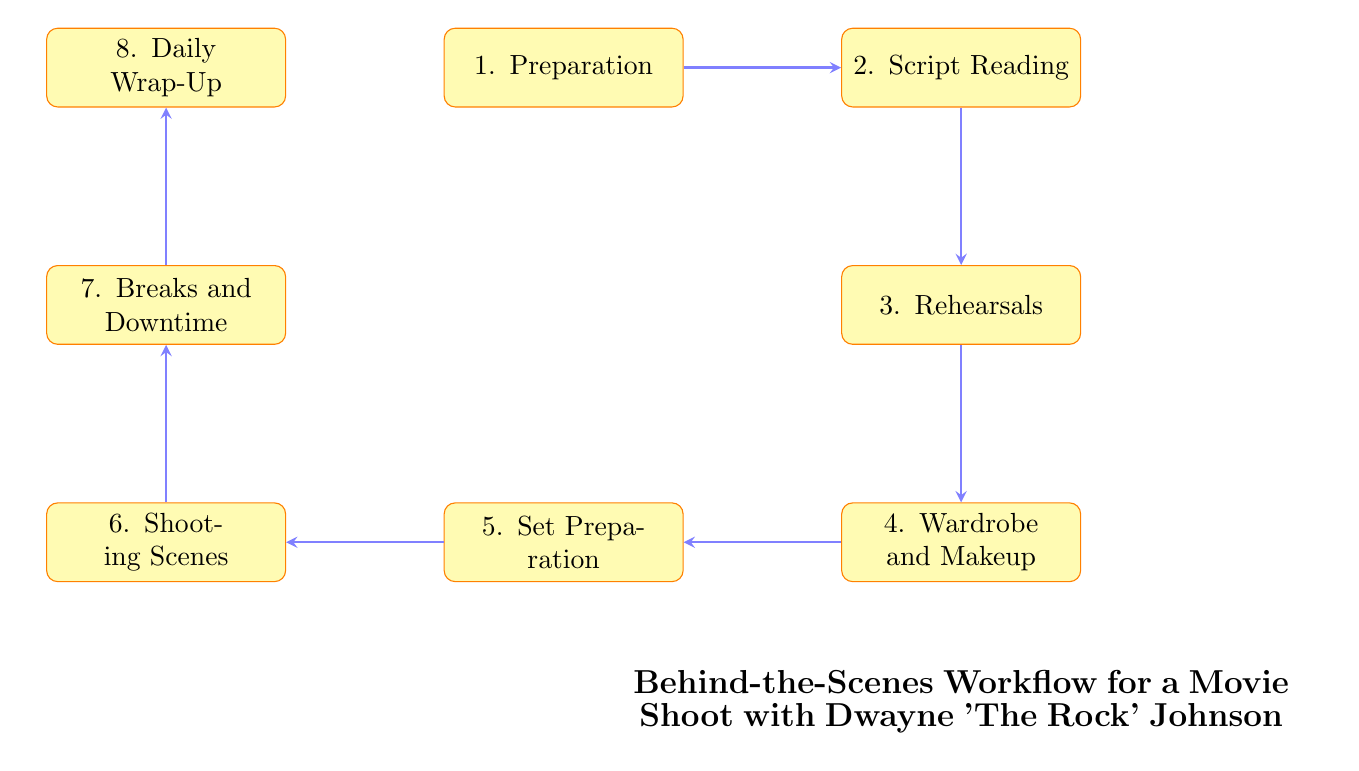What is the first step in the workflow? The diagram indicates that the first step is "Preparation", which is the initial meeting and planning session with directors and crew.
Answer: Preparation How many steps are there in the workflow? By counting the nodes in the flow chart, we find there are a total of 8 distinct steps in the workflow.
Answer: 8 What follows after Script Reading? The flow chart shows that "Rehearsals" follow after "Script Reading", indicating that rehearsals are performed with the main cast and stunt team after the script is read.
Answer: Rehearsals Which node comes before Set Preparation? In the flow chart, "Wardrobe and Makeup" comes right before "Set Preparation", indicating that Dwayne Johnson goes through wardrobe fittings and makeup before the set is prepared.
Answer: Wardrobe and Makeup What is the final step in the workflow? The diagram clearly shows that the last step in the workflow is "Daily Wrap-Up", which includes an end-of-day review of footage and planning for the next day's shoot.
Answer: Daily Wrap-Up What connects Shooting Scenes to Breaks and Downtime? The diagram indicates that "Shooting Scenes" directly leads to "Breaks and Downtime", suggesting that after scenes are shot, there are designated breaks where Dwayne interacts with the crew.
Answer: Shooting Scenes How many edges are there in the diagram? By counting the connections between nodes, it is established that there are 7 edges in the flow chart connecting the various steps of the workflow.
Answer: 7 What activities occur during Breaks and Downtime? According to the diagram, during "Breaks and Downtime", moments of interaction between Dwayne and the crew are captured, emphasizing the informal aspect of the workflow during these breaks.
Answer: Interacting with the crew 